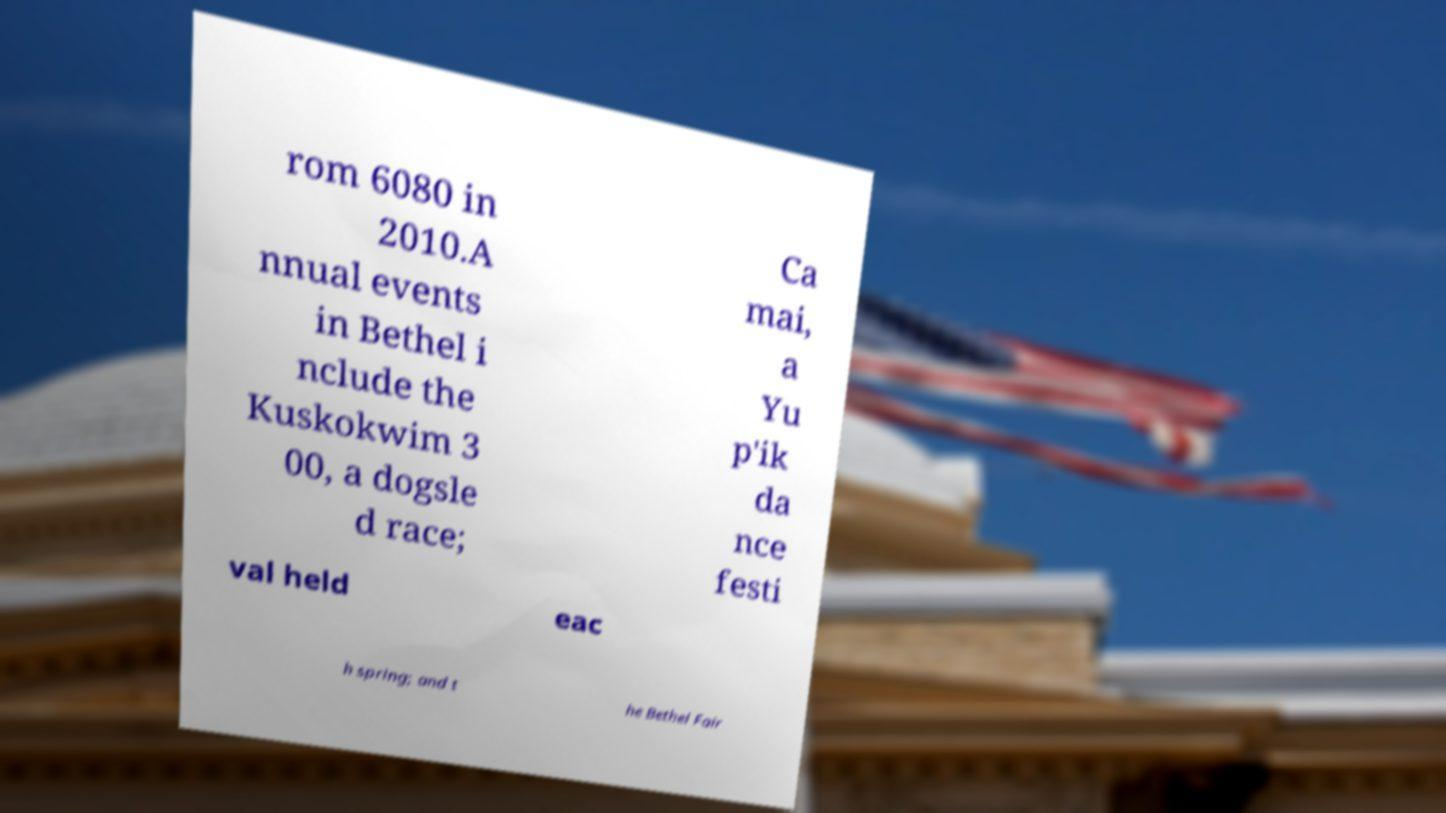For documentation purposes, I need the text within this image transcribed. Could you provide that? rom 6080 in 2010.A nnual events in Bethel i nclude the Kuskokwim 3 00, a dogsle d race; Ca mai, a Yu p'ik da nce festi val held eac h spring; and t he Bethel Fair 